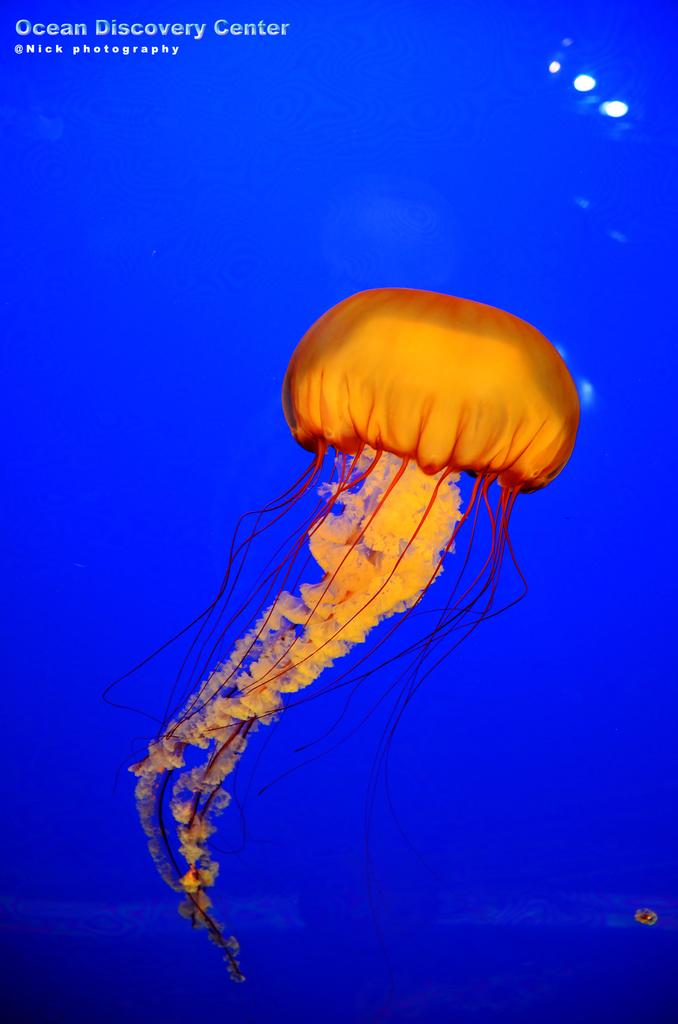What type of sea creature is in the image? There is a jellyfish in the image. What other type of fish can be seen in the image? There is an orange fish in the image. What color is the background of the image? The background of the image is blue. What is the flavor of the company logo on the jellyfish? There is no company logo or flavor mentioned in the image, as it features a jellyfish and an orange fish in a blue background. 